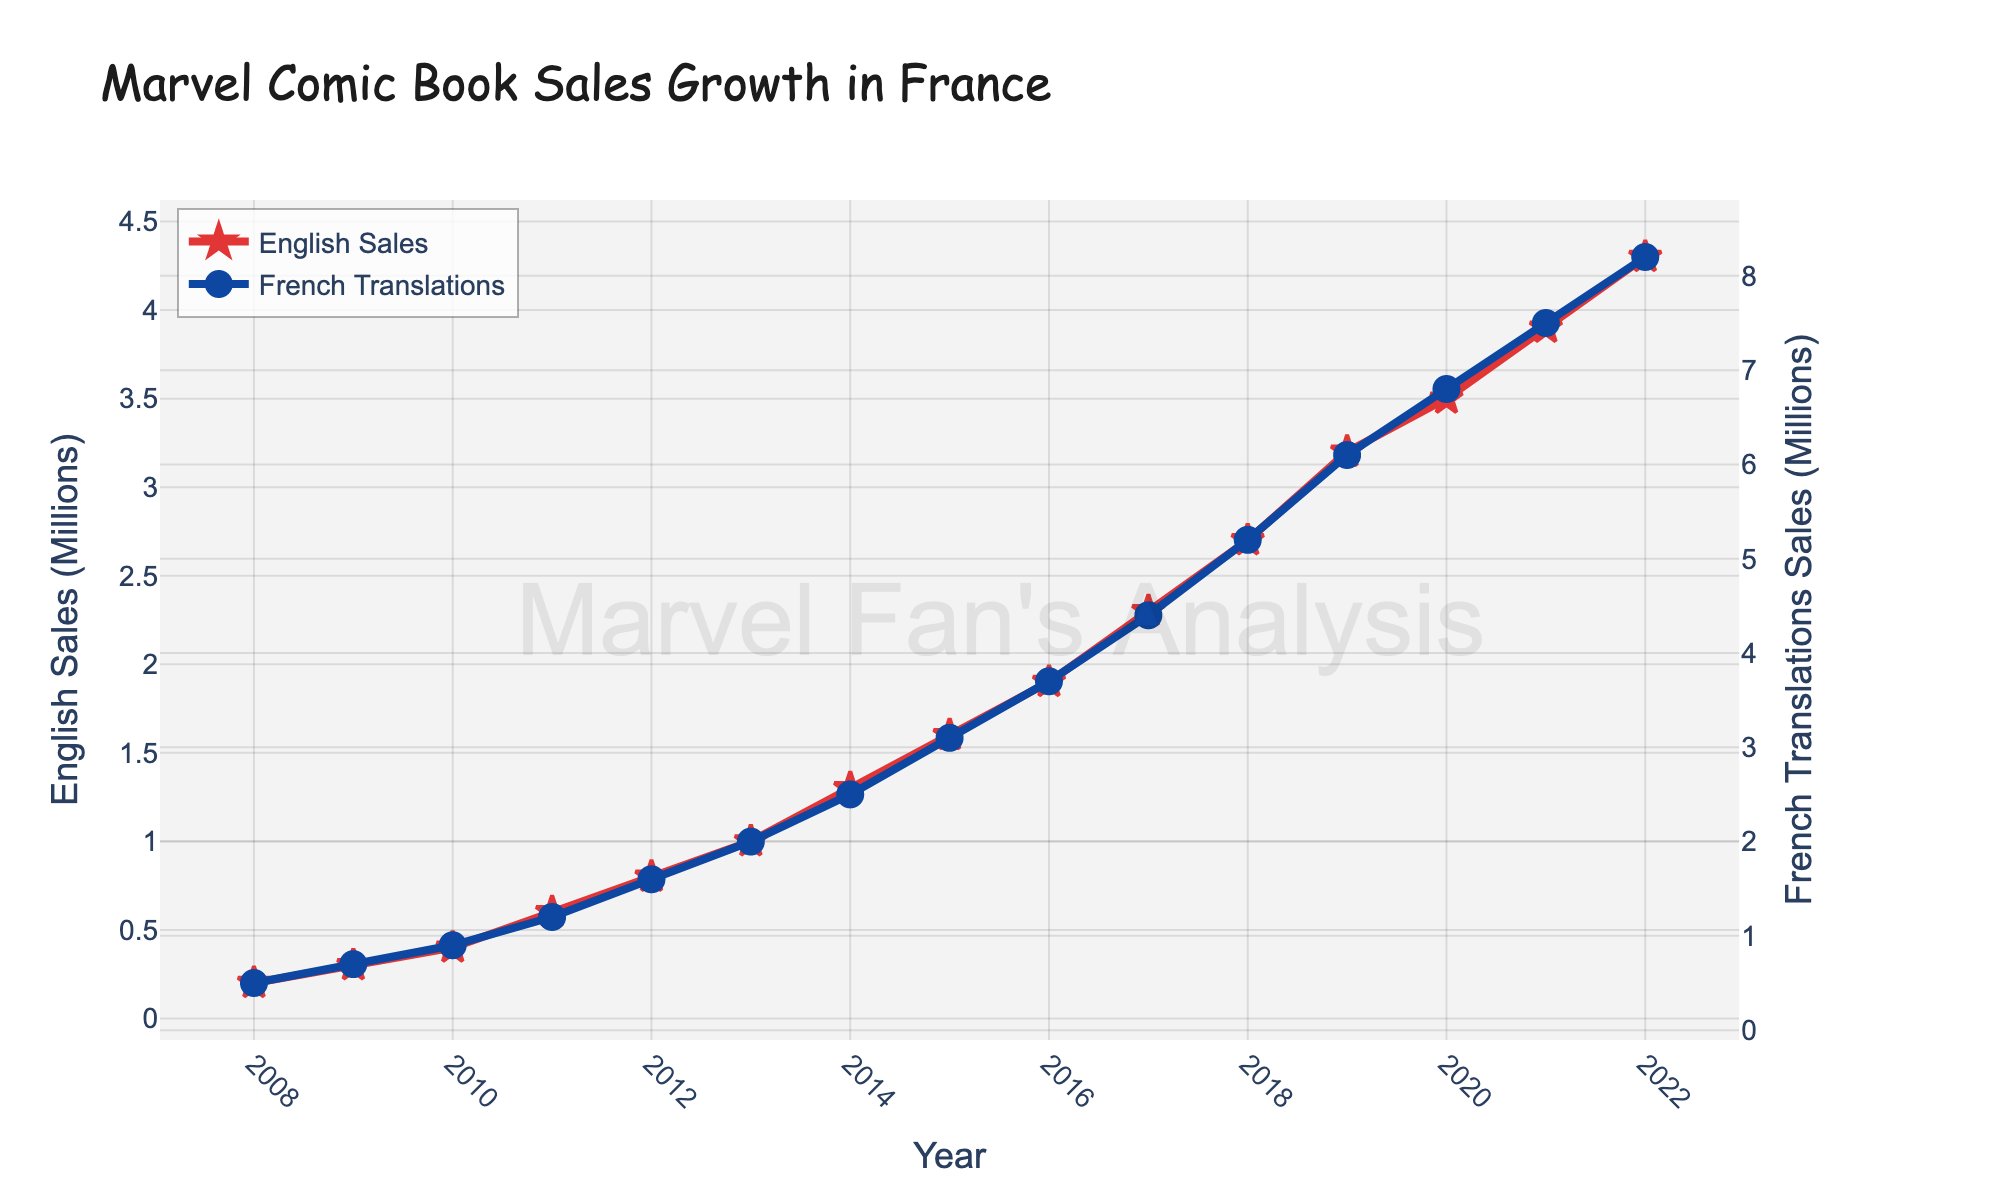Which year saw the highest sales of Marvel comics in French translations? Looking at the line representing French translations, we find that the last data point (2022) has the highest value.
Answer: 2022 How much did English sales increase from 2008 to 2022? Subtract the English sales in 2008 (0.2 million) from the sales in 2022 (4.3 million). (4.3 - 0.2 = 4.1)
Answer: 4.1 million Which type of sales showed a higher growth rate over the years, English or French translations? Compare the trends of both lines. Although both increase, the French translations line appears to have a steeper incline, indicating higher growth.
Answer: French translations What was the combined sales figure of English and French translations in 2014? Add the English sales (1.3 million) and the French translations sales (2.5 million) for the year 2014. (1.3 + 2.5 = 3.8)
Answer: 3.8 million In which year did the sales for English comics reach 3 million? Locate the point on the English sales line which corresponds to 3 million, which occurs in the year 2019.
Answer: 2019 By how much did French translations sales exceed English sales in the year 2012? Subtract English sales (0.8 million) from French translations sales (1.6 million) for 2012. (1.6 - 0.8 = 0.8)
Answer: 0.8 million Which year had the smallest difference between English and French translations sales? Compare the differences year by year; in 2008, the smallest difference is evident (0.5 - 0.2 = 0.3).
Answer: 2008 What are the visual attributes used to distinguish the English and French translations sales lines? The English sales line is red with star markers, and the French translations line is blue with circle markers.
Answer: Red with star markers and blue with circle markers 